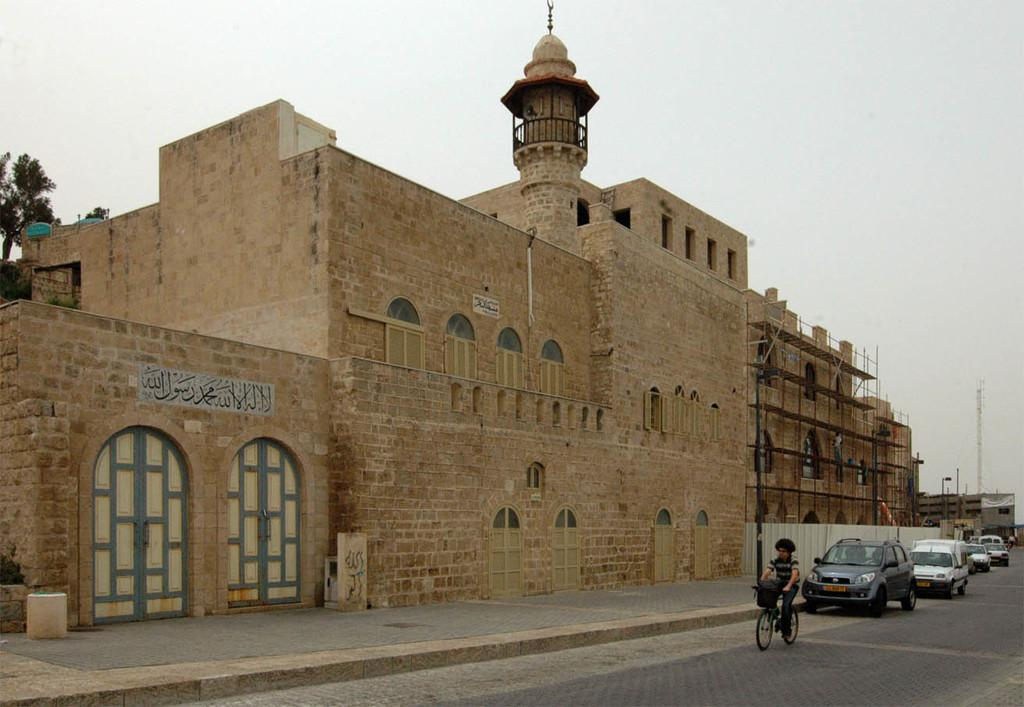What type of vehicles are on the road in the image? There are cars on the road in the image. What mode of transportation is the person using in the image? The person is riding a bicycle. What type of structures can be seen in the image? There are buildings in the image. What objects are present in the image that are not vehicles or structures? There are boards, doors, poles, and trees in the image. What is visible in the background of the image? The sky is visible in the background of the image. Can you tell me how many ducks are sitting on the boards in the image? There are no ducks present in the image; it features cars, a person on a bicycle, buildings, boards, doors, poles, trees, and the sky. What type of legal advice is the lawyer giving in the image? There is no lawyer present in the image, as it focuses on vehicles, a person on a bicycle, structures, and other objects. 